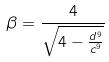<formula> <loc_0><loc_0><loc_500><loc_500>\beta = \frac { 4 } { \sqrt { 4 - \frac { d ^ { 9 } } { c ^ { 9 } } } }</formula> 